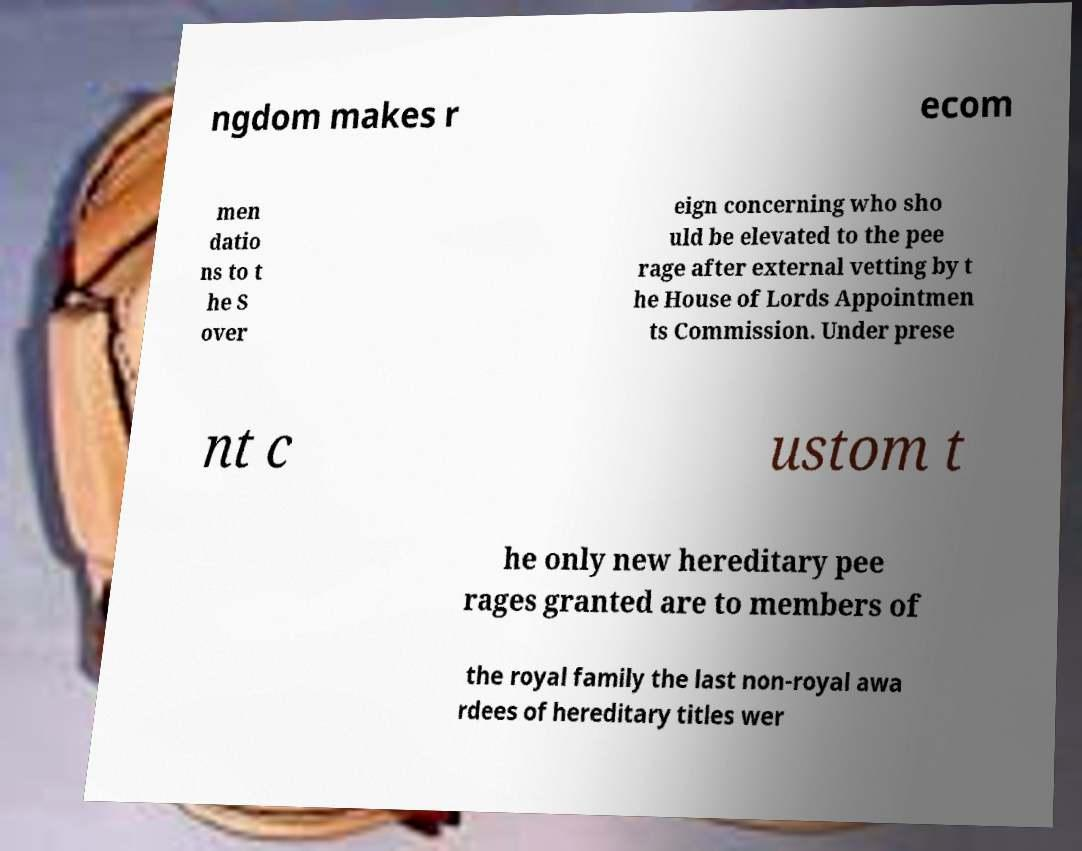There's text embedded in this image that I need extracted. Can you transcribe it verbatim? ngdom makes r ecom men datio ns to t he S over eign concerning who sho uld be elevated to the pee rage after external vetting by t he House of Lords Appointmen ts Commission. Under prese nt c ustom t he only new hereditary pee rages granted are to members of the royal family the last non-royal awa rdees of hereditary titles wer 